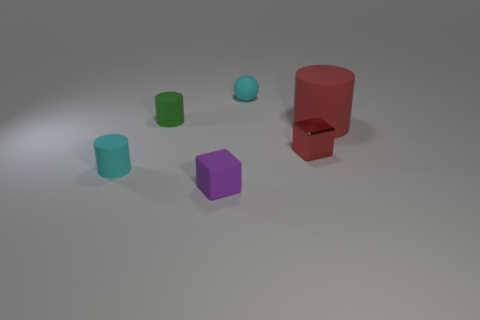What shape is the small matte object that is the same color as the small ball?
Your response must be concise. Cylinder. What material is the small object that is both in front of the small red shiny thing and behind the purple cube?
Provide a short and direct response. Rubber. What is the size of the cyan cylinder?
Your response must be concise. Small. What number of large red things are left of the rubber cylinder that is to the left of the tiny matte cylinder that is behind the red matte object?
Offer a very short reply. 0. There is a small cyan thing behind the small matte cylinder behind the big cylinder; what is its shape?
Your response must be concise. Sphere. What is the size of the green rubber object that is the same shape as the large red object?
Your answer should be compact. Small. Is there anything else that is the same size as the cyan rubber sphere?
Give a very brief answer. Yes. There is a small object to the right of the sphere; what is its color?
Keep it short and to the point. Red. What is the material of the cube that is on the left side of the cyan matte object that is behind the cylinder that is to the left of the tiny green rubber cylinder?
Offer a very short reply. Rubber. There is a cyan thing that is to the right of the small cyan matte object that is to the left of the purple object; how big is it?
Ensure brevity in your answer.  Small. 